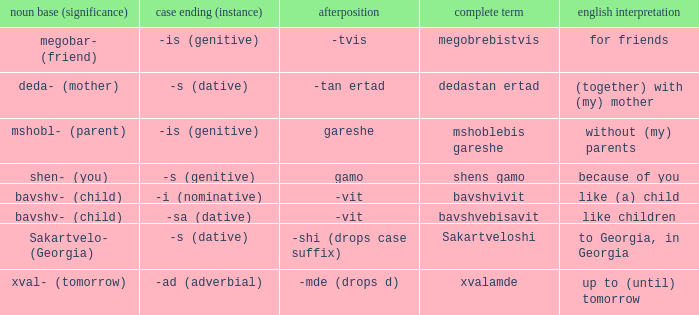What is Case Suffix (Case), when Postposition is "-mde (drops d)"? -ad (adverbial). 